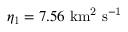<formula> <loc_0><loc_0><loc_500><loc_500>\eta _ { 1 } = 7 . 5 6 \ k m ^ { 2 } \ s ^ { - 1 }</formula> 